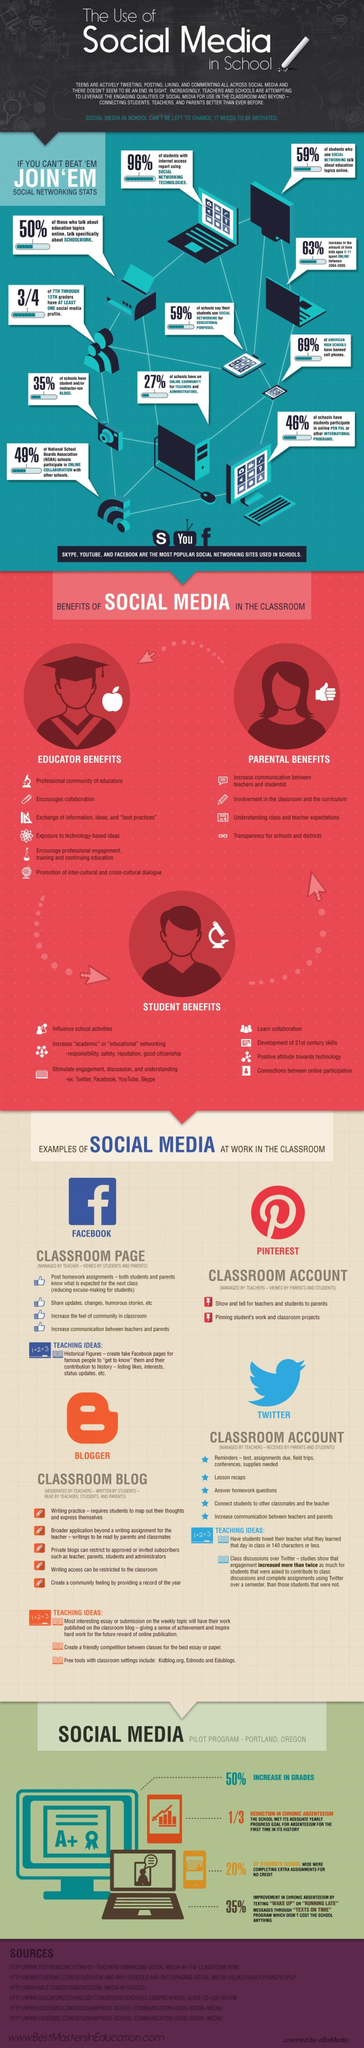How many points are under the heading "Educator benefits"?
Answer the question with a short phrase. 6 What percentage of American high schools have not banned cell phones? 31% What percentage of schools have no online community for teachers and administrators? 73% How many points are under the heading "Parental benefits"? 4 